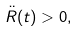Convert formula to latex. <formula><loc_0><loc_0><loc_500><loc_500>\ddot { R } ( t ) > 0 ,</formula> 